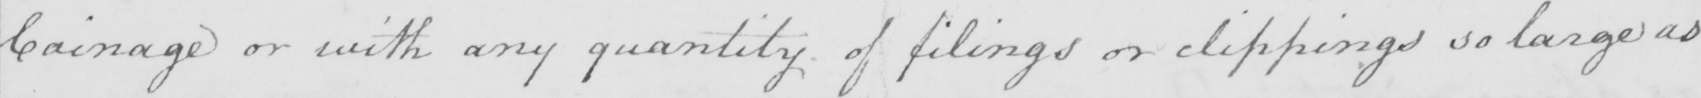What does this handwritten line say? Coinage or with any quantity of filings or clippings so large as 